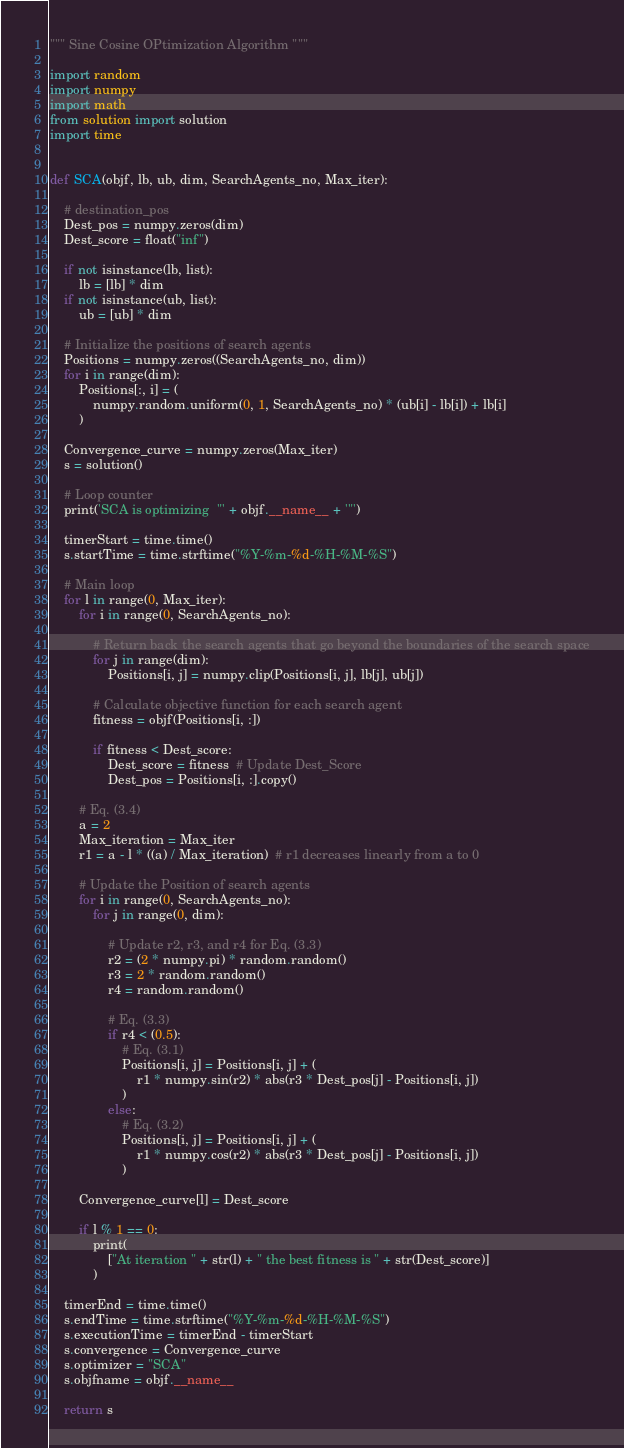Convert code to text. <code><loc_0><loc_0><loc_500><loc_500><_Python_>""" Sine Cosine OPtimization Algorithm """

import random
import numpy
import math
from solution import solution
import time


def SCA(objf, lb, ub, dim, SearchAgents_no, Max_iter):

    # destination_pos
    Dest_pos = numpy.zeros(dim)
    Dest_score = float("inf")

    if not isinstance(lb, list):
        lb = [lb] * dim
    if not isinstance(ub, list):
        ub = [ub] * dim

    # Initialize the positions of search agents
    Positions = numpy.zeros((SearchAgents_no, dim))
    for i in range(dim):
        Positions[:, i] = (
            numpy.random.uniform(0, 1, SearchAgents_no) * (ub[i] - lb[i]) + lb[i]
        )

    Convergence_curve = numpy.zeros(Max_iter)
    s = solution()

    # Loop counter
    print('SCA is optimizing  "' + objf.__name__ + '"')

    timerStart = time.time()
    s.startTime = time.strftime("%Y-%m-%d-%H-%M-%S")

    # Main loop
    for l in range(0, Max_iter):
        for i in range(0, SearchAgents_no):

            # Return back the search agents that go beyond the boundaries of the search space
            for j in range(dim):
                Positions[i, j] = numpy.clip(Positions[i, j], lb[j], ub[j])

            # Calculate objective function for each search agent
            fitness = objf(Positions[i, :])

            if fitness < Dest_score:
                Dest_score = fitness  # Update Dest_Score
                Dest_pos = Positions[i, :].copy()

        # Eq. (3.4)
        a = 2
        Max_iteration = Max_iter
        r1 = a - l * ((a) / Max_iteration)  # r1 decreases linearly from a to 0

        # Update the Position of search agents
        for i in range(0, SearchAgents_no):
            for j in range(0, dim):

                # Update r2, r3, and r4 for Eq. (3.3)
                r2 = (2 * numpy.pi) * random.random()
                r3 = 2 * random.random()
                r4 = random.random()

                # Eq. (3.3)
                if r4 < (0.5):
                    # Eq. (3.1)
                    Positions[i, j] = Positions[i, j] + (
                        r1 * numpy.sin(r2) * abs(r3 * Dest_pos[j] - Positions[i, j])
                    )
                else:
                    # Eq. (3.2)
                    Positions[i, j] = Positions[i, j] + (
                        r1 * numpy.cos(r2) * abs(r3 * Dest_pos[j] - Positions[i, j])
                    )

        Convergence_curve[l] = Dest_score

        if l % 1 == 0:
            print(
                ["At iteration " + str(l) + " the best fitness is " + str(Dest_score)]
            )

    timerEnd = time.time()
    s.endTime = time.strftime("%Y-%m-%d-%H-%M-%S")
    s.executionTime = timerEnd - timerStart
    s.convergence = Convergence_curve
    s.optimizer = "SCA"
    s.objfname = objf.__name__

    return s
</code> 